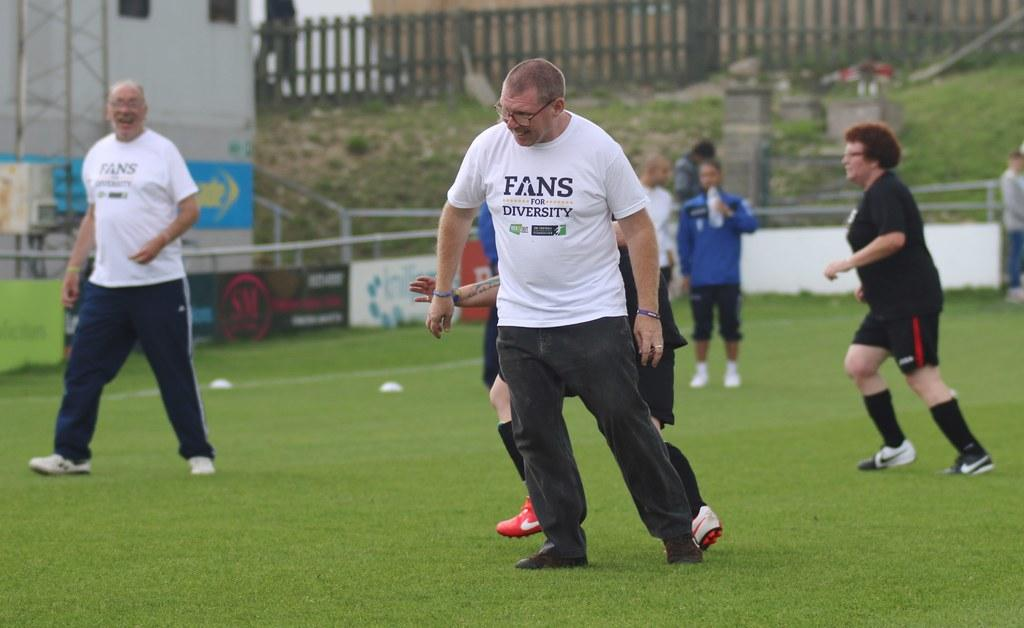<image>
Share a concise interpretation of the image provided. the man in the front is wearing a tshirt with word Fans on it 